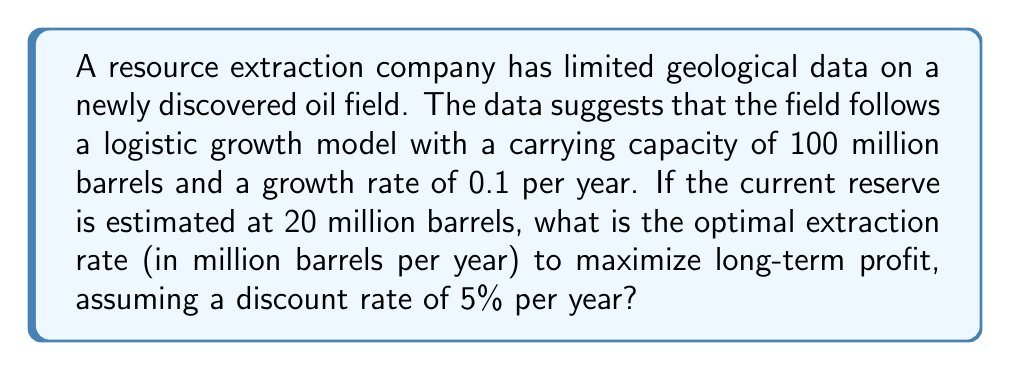Can you answer this question? To solve this problem, we'll use the concept of optimal resource extraction rate for a renewable resource with logistic growth, also known as the Golden Rule of Resource Extraction.

Step 1: Identify the logistic growth model parameters
- Carrying capacity (K) = 100 million barrels
- Growth rate (r) = 0.1 per year
- Current reserve (x) = 20 million barrels
- Discount rate (δ) = 0.05 per year

Step 2: Apply the Golden Rule formula
The optimal extraction rate (h*) is given by:

$$ h^* = rx(1 - \frac{x}{K}) - \frac{\delta x}{2}(1 - \frac{x}{K}) $$

Step 3: Substitute the values into the formula
$$ h^* = 0.1 \cdot 20(1 - \frac{20}{100}) - \frac{0.05 \cdot 20}{2}(1 - \frac{20}{100}) $$

Step 4: Simplify and calculate
$$ h^* = 0.1 \cdot 20 \cdot 0.8 - 0.05 \cdot 10 \cdot 0.8 $$
$$ h^* = 1.6 - 0.4 $$
$$ h^* = 1.2 $$

Therefore, the optimal extraction rate is 1.2 million barrels per year.
Answer: 1.2 million barrels per year 